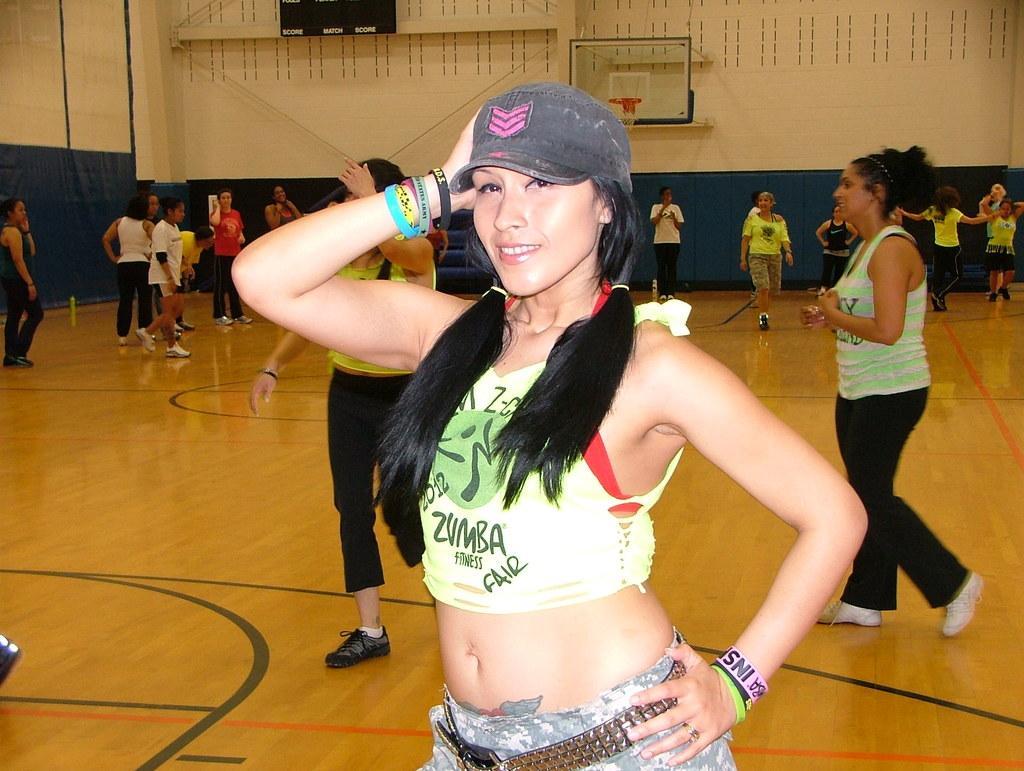Describe this image in one or two sentences. There is a lady wearing cap and wristbands. In the background there are many people. Also there is a wall. On the wall there is a board with basketball net. 